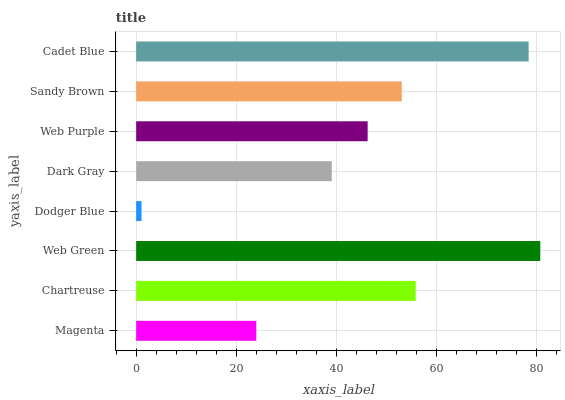Is Dodger Blue the minimum?
Answer yes or no. Yes. Is Web Green the maximum?
Answer yes or no. Yes. Is Chartreuse the minimum?
Answer yes or no. No. Is Chartreuse the maximum?
Answer yes or no. No. Is Chartreuse greater than Magenta?
Answer yes or no. Yes. Is Magenta less than Chartreuse?
Answer yes or no. Yes. Is Magenta greater than Chartreuse?
Answer yes or no. No. Is Chartreuse less than Magenta?
Answer yes or no. No. Is Sandy Brown the high median?
Answer yes or no. Yes. Is Web Purple the low median?
Answer yes or no. Yes. Is Magenta the high median?
Answer yes or no. No. Is Sandy Brown the low median?
Answer yes or no. No. 